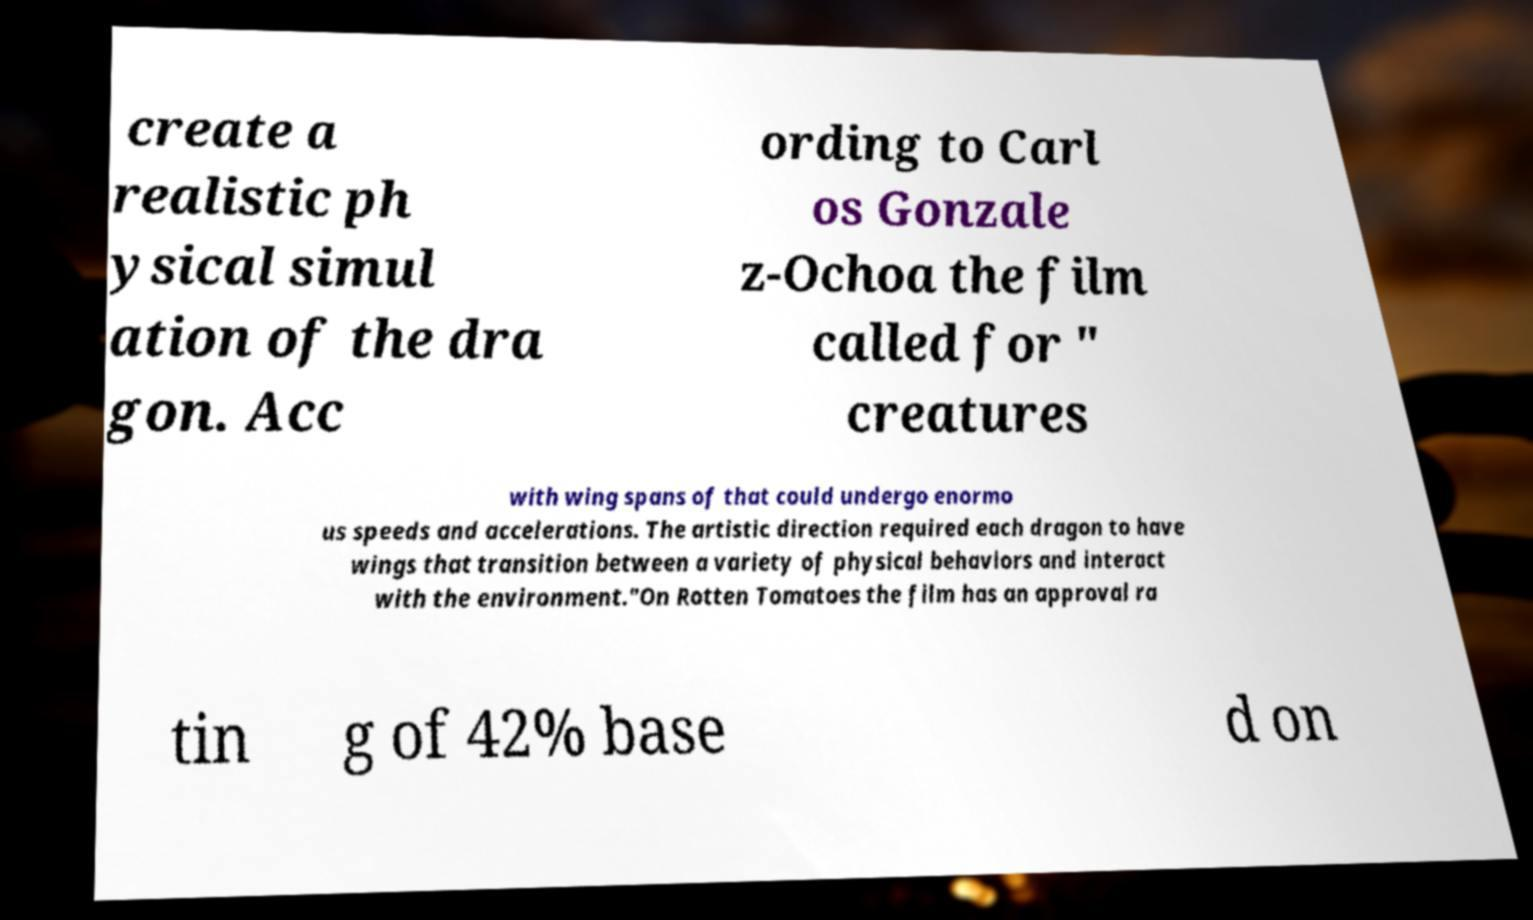Please identify and transcribe the text found in this image. create a realistic ph ysical simul ation of the dra gon. Acc ording to Carl os Gonzale z-Ochoa the film called for " creatures with wing spans of that could undergo enormo us speeds and accelerations. The artistic direction required each dragon to have wings that transition between a variety of physical behaviors and interact with the environment."On Rotten Tomatoes the film has an approval ra tin g of 42% base d on 